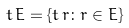Convert formula to latex. <formula><loc_0><loc_0><loc_500><loc_500>t \, E = \{ t \, r \colon r \in E \}</formula> 